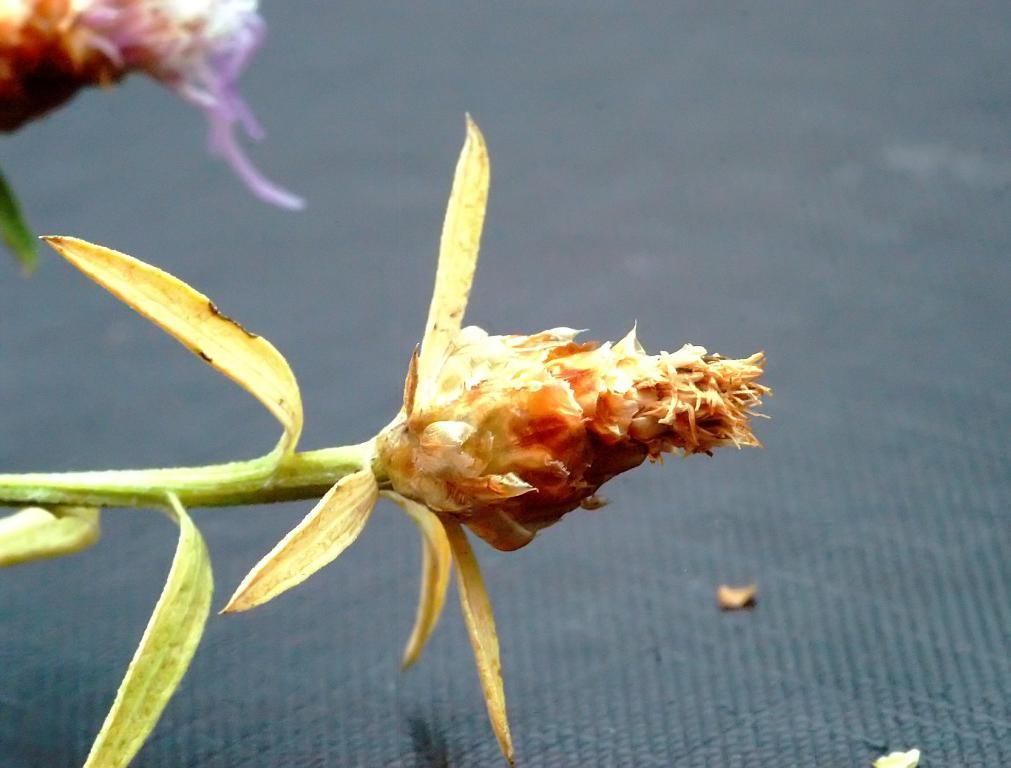What type of flower is present in the image? There is a brown color flower in the image. What colors can be seen in the leaves in the image? The leaves in the image have yellow and green colors. What is the color of the floor in the image? The floor in the image is in grey color. What type of engine can be seen in the image? There is no engine present in the image; it features a brown flower, yellow and green leaves, and a grey floor. How many bikes are visible in the image? There are no bikes present in the image. 